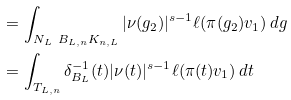Convert formula to latex. <formula><loc_0><loc_0><loc_500><loc_500>& = \int _ { N _ { L } \ B _ { L , n } K _ { n , L } } { | \nu ( g _ { 2 } ) | ^ { s - 1 } \ell ( \pi ( g _ { 2 } ) v _ { 1 } ) \, d g } \\ & = \int _ { T _ { L , n } } { \delta _ { B _ { L } } ^ { - 1 } ( t ) | \nu ( t ) | ^ { s - 1 } \ell ( \pi ( t ) v _ { 1 } ) \, d t }</formula> 